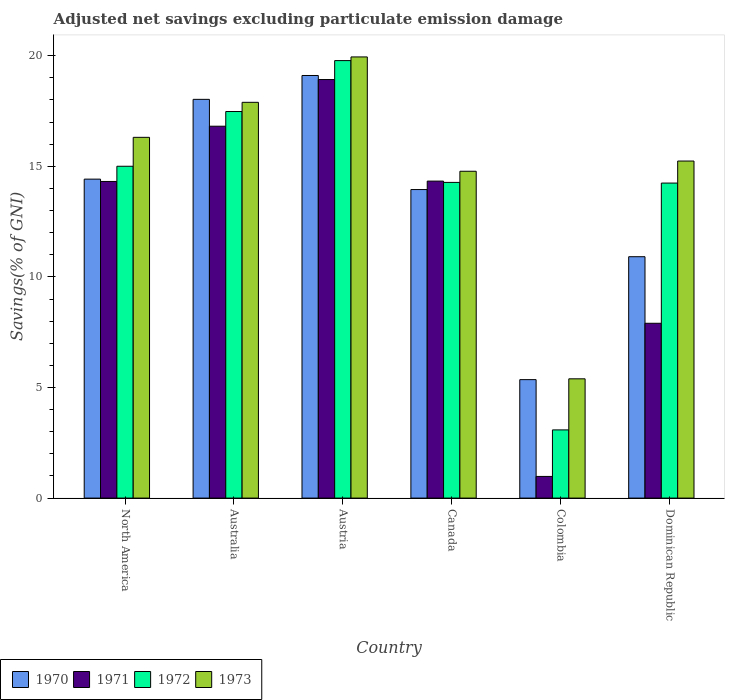How many different coloured bars are there?
Ensure brevity in your answer.  4. How many groups of bars are there?
Your response must be concise. 6. Are the number of bars per tick equal to the number of legend labels?
Offer a very short reply. Yes. How many bars are there on the 6th tick from the right?
Offer a very short reply. 4. What is the label of the 1st group of bars from the left?
Provide a short and direct response. North America. What is the adjusted net savings in 1972 in Colombia?
Make the answer very short. 3.08. Across all countries, what is the maximum adjusted net savings in 1971?
Provide a succinct answer. 18.92. Across all countries, what is the minimum adjusted net savings in 1970?
Ensure brevity in your answer.  5.36. In which country was the adjusted net savings in 1971 maximum?
Your answer should be compact. Austria. What is the total adjusted net savings in 1970 in the graph?
Your answer should be compact. 81.77. What is the difference between the adjusted net savings in 1971 in Austria and that in Dominican Republic?
Provide a short and direct response. 11.02. What is the difference between the adjusted net savings in 1973 in Dominican Republic and the adjusted net savings in 1972 in Australia?
Your response must be concise. -2.24. What is the average adjusted net savings in 1972 per country?
Provide a short and direct response. 13.98. What is the difference between the adjusted net savings of/in 1971 and adjusted net savings of/in 1972 in Canada?
Make the answer very short. 0.06. In how many countries, is the adjusted net savings in 1970 greater than 13 %?
Offer a terse response. 4. What is the ratio of the adjusted net savings in 1971 in Canada to that in Colombia?
Provide a short and direct response. 14.64. Is the adjusted net savings in 1972 in Australia less than that in Canada?
Your answer should be very brief. No. What is the difference between the highest and the second highest adjusted net savings in 1970?
Offer a very short reply. -1.08. What is the difference between the highest and the lowest adjusted net savings in 1973?
Give a very brief answer. 14.55. Is the sum of the adjusted net savings in 1973 in Canada and Colombia greater than the maximum adjusted net savings in 1970 across all countries?
Your answer should be very brief. Yes. Is it the case that in every country, the sum of the adjusted net savings in 1970 and adjusted net savings in 1972 is greater than the sum of adjusted net savings in 1971 and adjusted net savings in 1973?
Give a very brief answer. No. What does the 3rd bar from the left in Dominican Republic represents?
Make the answer very short. 1972. Is it the case that in every country, the sum of the adjusted net savings in 1973 and adjusted net savings in 1971 is greater than the adjusted net savings in 1970?
Your response must be concise. Yes. How many countries are there in the graph?
Provide a succinct answer. 6. Are the values on the major ticks of Y-axis written in scientific E-notation?
Provide a short and direct response. No. How are the legend labels stacked?
Keep it short and to the point. Horizontal. What is the title of the graph?
Give a very brief answer. Adjusted net savings excluding particulate emission damage. What is the label or title of the Y-axis?
Keep it short and to the point. Savings(% of GNI). What is the Savings(% of GNI) of 1970 in North America?
Ensure brevity in your answer.  14.42. What is the Savings(% of GNI) of 1971 in North America?
Provide a short and direct response. 14.31. What is the Savings(% of GNI) of 1972 in North America?
Make the answer very short. 15. What is the Savings(% of GNI) in 1973 in North America?
Make the answer very short. 16.31. What is the Savings(% of GNI) of 1970 in Australia?
Ensure brevity in your answer.  18.03. What is the Savings(% of GNI) of 1971 in Australia?
Give a very brief answer. 16.81. What is the Savings(% of GNI) in 1972 in Australia?
Offer a terse response. 17.48. What is the Savings(% of GNI) of 1973 in Australia?
Keep it short and to the point. 17.89. What is the Savings(% of GNI) in 1970 in Austria?
Give a very brief answer. 19.11. What is the Savings(% of GNI) in 1971 in Austria?
Provide a short and direct response. 18.92. What is the Savings(% of GNI) in 1972 in Austria?
Provide a succinct answer. 19.78. What is the Savings(% of GNI) in 1973 in Austria?
Your response must be concise. 19.94. What is the Savings(% of GNI) in 1970 in Canada?
Your answer should be compact. 13.95. What is the Savings(% of GNI) of 1971 in Canada?
Your answer should be compact. 14.33. What is the Savings(% of GNI) of 1972 in Canada?
Your answer should be compact. 14.27. What is the Savings(% of GNI) of 1973 in Canada?
Keep it short and to the point. 14.78. What is the Savings(% of GNI) of 1970 in Colombia?
Offer a very short reply. 5.36. What is the Savings(% of GNI) in 1971 in Colombia?
Keep it short and to the point. 0.98. What is the Savings(% of GNI) in 1972 in Colombia?
Your response must be concise. 3.08. What is the Savings(% of GNI) in 1973 in Colombia?
Ensure brevity in your answer.  5.39. What is the Savings(% of GNI) of 1970 in Dominican Republic?
Provide a short and direct response. 10.91. What is the Savings(% of GNI) of 1971 in Dominican Republic?
Ensure brevity in your answer.  7.9. What is the Savings(% of GNI) in 1972 in Dominican Republic?
Make the answer very short. 14.24. What is the Savings(% of GNI) of 1973 in Dominican Republic?
Ensure brevity in your answer.  15.24. Across all countries, what is the maximum Savings(% of GNI) in 1970?
Make the answer very short. 19.11. Across all countries, what is the maximum Savings(% of GNI) of 1971?
Your answer should be compact. 18.92. Across all countries, what is the maximum Savings(% of GNI) in 1972?
Your response must be concise. 19.78. Across all countries, what is the maximum Savings(% of GNI) in 1973?
Your answer should be compact. 19.94. Across all countries, what is the minimum Savings(% of GNI) of 1970?
Provide a short and direct response. 5.36. Across all countries, what is the minimum Savings(% of GNI) in 1971?
Offer a very short reply. 0.98. Across all countries, what is the minimum Savings(% of GNI) of 1972?
Provide a succinct answer. 3.08. Across all countries, what is the minimum Savings(% of GNI) in 1973?
Offer a very short reply. 5.39. What is the total Savings(% of GNI) of 1970 in the graph?
Give a very brief answer. 81.77. What is the total Savings(% of GNI) in 1971 in the graph?
Offer a terse response. 73.26. What is the total Savings(% of GNI) in 1972 in the graph?
Make the answer very short. 83.85. What is the total Savings(% of GNI) in 1973 in the graph?
Ensure brevity in your answer.  89.55. What is the difference between the Savings(% of GNI) of 1970 in North America and that in Australia?
Offer a very short reply. -3.61. What is the difference between the Savings(% of GNI) of 1971 in North America and that in Australia?
Your answer should be very brief. -2.5. What is the difference between the Savings(% of GNI) in 1972 in North America and that in Australia?
Offer a terse response. -2.47. What is the difference between the Savings(% of GNI) of 1973 in North America and that in Australia?
Offer a terse response. -1.58. What is the difference between the Savings(% of GNI) of 1970 in North America and that in Austria?
Provide a succinct answer. -4.69. What is the difference between the Savings(% of GNI) in 1971 in North America and that in Austria?
Keep it short and to the point. -4.61. What is the difference between the Savings(% of GNI) in 1972 in North America and that in Austria?
Provide a short and direct response. -4.78. What is the difference between the Savings(% of GNI) of 1973 in North America and that in Austria?
Ensure brevity in your answer.  -3.63. What is the difference between the Savings(% of GNI) of 1970 in North America and that in Canada?
Offer a very short reply. 0.47. What is the difference between the Savings(% of GNI) in 1971 in North America and that in Canada?
Ensure brevity in your answer.  -0.02. What is the difference between the Savings(% of GNI) in 1972 in North America and that in Canada?
Keep it short and to the point. 0.73. What is the difference between the Savings(% of GNI) of 1973 in North America and that in Canada?
Give a very brief answer. 1.53. What is the difference between the Savings(% of GNI) of 1970 in North America and that in Colombia?
Your answer should be very brief. 9.06. What is the difference between the Savings(% of GNI) in 1971 in North America and that in Colombia?
Offer a very short reply. 13.34. What is the difference between the Savings(% of GNI) of 1972 in North America and that in Colombia?
Your response must be concise. 11.92. What is the difference between the Savings(% of GNI) of 1973 in North America and that in Colombia?
Offer a terse response. 10.92. What is the difference between the Savings(% of GNI) of 1970 in North America and that in Dominican Republic?
Provide a succinct answer. 3.51. What is the difference between the Savings(% of GNI) of 1971 in North America and that in Dominican Republic?
Offer a very short reply. 6.41. What is the difference between the Savings(% of GNI) in 1972 in North America and that in Dominican Republic?
Your answer should be very brief. 0.76. What is the difference between the Savings(% of GNI) of 1973 in North America and that in Dominican Republic?
Keep it short and to the point. 1.07. What is the difference between the Savings(% of GNI) of 1970 in Australia and that in Austria?
Keep it short and to the point. -1.08. What is the difference between the Savings(% of GNI) of 1971 in Australia and that in Austria?
Give a very brief answer. -2.11. What is the difference between the Savings(% of GNI) of 1972 in Australia and that in Austria?
Your answer should be compact. -2.3. What is the difference between the Savings(% of GNI) of 1973 in Australia and that in Austria?
Offer a terse response. -2.05. What is the difference between the Savings(% of GNI) of 1970 in Australia and that in Canada?
Make the answer very short. 4.08. What is the difference between the Savings(% of GNI) of 1971 in Australia and that in Canada?
Give a very brief answer. 2.48. What is the difference between the Savings(% of GNI) of 1972 in Australia and that in Canada?
Offer a very short reply. 3.2. What is the difference between the Savings(% of GNI) in 1973 in Australia and that in Canada?
Your response must be concise. 3.12. What is the difference between the Savings(% of GNI) of 1970 in Australia and that in Colombia?
Offer a very short reply. 12.67. What is the difference between the Savings(% of GNI) of 1971 in Australia and that in Colombia?
Your answer should be compact. 15.83. What is the difference between the Savings(% of GNI) in 1972 in Australia and that in Colombia?
Offer a very short reply. 14.39. What is the difference between the Savings(% of GNI) of 1973 in Australia and that in Colombia?
Your answer should be compact. 12.5. What is the difference between the Savings(% of GNI) of 1970 in Australia and that in Dominican Republic?
Provide a succinct answer. 7.11. What is the difference between the Savings(% of GNI) in 1971 in Australia and that in Dominican Republic?
Make the answer very short. 8.91. What is the difference between the Savings(% of GNI) in 1972 in Australia and that in Dominican Republic?
Give a very brief answer. 3.23. What is the difference between the Savings(% of GNI) of 1973 in Australia and that in Dominican Republic?
Offer a very short reply. 2.65. What is the difference between the Savings(% of GNI) of 1970 in Austria and that in Canada?
Offer a very short reply. 5.16. What is the difference between the Savings(% of GNI) of 1971 in Austria and that in Canada?
Provide a succinct answer. 4.59. What is the difference between the Savings(% of GNI) of 1972 in Austria and that in Canada?
Your answer should be very brief. 5.51. What is the difference between the Savings(% of GNI) in 1973 in Austria and that in Canada?
Provide a short and direct response. 5.17. What is the difference between the Savings(% of GNI) in 1970 in Austria and that in Colombia?
Provide a short and direct response. 13.75. What is the difference between the Savings(% of GNI) in 1971 in Austria and that in Colombia?
Your response must be concise. 17.94. What is the difference between the Savings(% of GNI) in 1972 in Austria and that in Colombia?
Provide a succinct answer. 16.7. What is the difference between the Savings(% of GNI) in 1973 in Austria and that in Colombia?
Provide a succinct answer. 14.55. What is the difference between the Savings(% of GNI) in 1970 in Austria and that in Dominican Republic?
Keep it short and to the point. 8.19. What is the difference between the Savings(% of GNI) in 1971 in Austria and that in Dominican Republic?
Give a very brief answer. 11.02. What is the difference between the Savings(% of GNI) in 1972 in Austria and that in Dominican Republic?
Offer a terse response. 5.54. What is the difference between the Savings(% of GNI) in 1973 in Austria and that in Dominican Republic?
Keep it short and to the point. 4.71. What is the difference between the Savings(% of GNI) of 1970 in Canada and that in Colombia?
Offer a very short reply. 8.59. What is the difference between the Savings(% of GNI) in 1971 in Canada and that in Colombia?
Your answer should be compact. 13.35. What is the difference between the Savings(% of GNI) in 1972 in Canada and that in Colombia?
Ensure brevity in your answer.  11.19. What is the difference between the Savings(% of GNI) in 1973 in Canada and that in Colombia?
Offer a very short reply. 9.38. What is the difference between the Savings(% of GNI) in 1970 in Canada and that in Dominican Republic?
Make the answer very short. 3.04. What is the difference between the Savings(% of GNI) in 1971 in Canada and that in Dominican Republic?
Your response must be concise. 6.43. What is the difference between the Savings(% of GNI) in 1972 in Canada and that in Dominican Republic?
Keep it short and to the point. 0.03. What is the difference between the Savings(% of GNI) in 1973 in Canada and that in Dominican Republic?
Give a very brief answer. -0.46. What is the difference between the Savings(% of GNI) of 1970 in Colombia and that in Dominican Republic?
Ensure brevity in your answer.  -5.56. What is the difference between the Savings(% of GNI) of 1971 in Colombia and that in Dominican Republic?
Offer a very short reply. -6.92. What is the difference between the Savings(% of GNI) in 1972 in Colombia and that in Dominican Republic?
Make the answer very short. -11.16. What is the difference between the Savings(% of GNI) of 1973 in Colombia and that in Dominican Republic?
Keep it short and to the point. -9.85. What is the difference between the Savings(% of GNI) of 1970 in North America and the Savings(% of GNI) of 1971 in Australia?
Provide a short and direct response. -2.39. What is the difference between the Savings(% of GNI) in 1970 in North America and the Savings(% of GNI) in 1972 in Australia?
Keep it short and to the point. -3.06. What is the difference between the Savings(% of GNI) in 1970 in North America and the Savings(% of GNI) in 1973 in Australia?
Offer a very short reply. -3.47. What is the difference between the Savings(% of GNI) in 1971 in North America and the Savings(% of GNI) in 1972 in Australia?
Ensure brevity in your answer.  -3.16. What is the difference between the Savings(% of GNI) of 1971 in North America and the Savings(% of GNI) of 1973 in Australia?
Provide a short and direct response. -3.58. What is the difference between the Savings(% of GNI) in 1972 in North America and the Savings(% of GNI) in 1973 in Australia?
Your answer should be very brief. -2.89. What is the difference between the Savings(% of GNI) of 1970 in North America and the Savings(% of GNI) of 1971 in Austria?
Give a very brief answer. -4.5. What is the difference between the Savings(% of GNI) in 1970 in North America and the Savings(% of GNI) in 1972 in Austria?
Offer a very short reply. -5.36. What is the difference between the Savings(% of GNI) of 1970 in North America and the Savings(% of GNI) of 1973 in Austria?
Offer a terse response. -5.52. What is the difference between the Savings(% of GNI) of 1971 in North America and the Savings(% of GNI) of 1972 in Austria?
Your answer should be compact. -5.46. What is the difference between the Savings(% of GNI) of 1971 in North America and the Savings(% of GNI) of 1973 in Austria?
Ensure brevity in your answer.  -5.63. What is the difference between the Savings(% of GNI) in 1972 in North America and the Savings(% of GNI) in 1973 in Austria?
Your answer should be very brief. -4.94. What is the difference between the Savings(% of GNI) in 1970 in North America and the Savings(% of GNI) in 1971 in Canada?
Ensure brevity in your answer.  0.09. What is the difference between the Savings(% of GNI) of 1970 in North America and the Savings(% of GNI) of 1972 in Canada?
Keep it short and to the point. 0.15. What is the difference between the Savings(% of GNI) of 1970 in North America and the Savings(% of GNI) of 1973 in Canada?
Ensure brevity in your answer.  -0.36. What is the difference between the Savings(% of GNI) of 1971 in North America and the Savings(% of GNI) of 1972 in Canada?
Your answer should be very brief. 0.04. What is the difference between the Savings(% of GNI) of 1971 in North America and the Savings(% of GNI) of 1973 in Canada?
Keep it short and to the point. -0.46. What is the difference between the Savings(% of GNI) in 1972 in North America and the Savings(% of GNI) in 1973 in Canada?
Your answer should be very brief. 0.23. What is the difference between the Savings(% of GNI) of 1970 in North America and the Savings(% of GNI) of 1971 in Colombia?
Give a very brief answer. 13.44. What is the difference between the Savings(% of GNI) in 1970 in North America and the Savings(% of GNI) in 1972 in Colombia?
Your answer should be very brief. 11.34. What is the difference between the Savings(% of GNI) of 1970 in North America and the Savings(% of GNI) of 1973 in Colombia?
Your answer should be compact. 9.03. What is the difference between the Savings(% of GNI) of 1971 in North America and the Savings(% of GNI) of 1972 in Colombia?
Make the answer very short. 11.23. What is the difference between the Savings(% of GNI) in 1971 in North America and the Savings(% of GNI) in 1973 in Colombia?
Give a very brief answer. 8.92. What is the difference between the Savings(% of GNI) in 1972 in North America and the Savings(% of GNI) in 1973 in Colombia?
Your response must be concise. 9.61. What is the difference between the Savings(% of GNI) in 1970 in North America and the Savings(% of GNI) in 1971 in Dominican Republic?
Your answer should be very brief. 6.52. What is the difference between the Savings(% of GNI) of 1970 in North America and the Savings(% of GNI) of 1972 in Dominican Republic?
Give a very brief answer. 0.18. What is the difference between the Savings(% of GNI) of 1970 in North America and the Savings(% of GNI) of 1973 in Dominican Republic?
Your answer should be compact. -0.82. What is the difference between the Savings(% of GNI) of 1971 in North America and the Savings(% of GNI) of 1972 in Dominican Republic?
Give a very brief answer. 0.07. What is the difference between the Savings(% of GNI) in 1971 in North America and the Savings(% of GNI) in 1973 in Dominican Republic?
Offer a terse response. -0.92. What is the difference between the Savings(% of GNI) in 1972 in North America and the Savings(% of GNI) in 1973 in Dominican Republic?
Your response must be concise. -0.24. What is the difference between the Savings(% of GNI) in 1970 in Australia and the Savings(% of GNI) in 1971 in Austria?
Provide a short and direct response. -0.9. What is the difference between the Savings(% of GNI) in 1970 in Australia and the Savings(% of GNI) in 1972 in Austria?
Your answer should be very brief. -1.75. What is the difference between the Savings(% of GNI) of 1970 in Australia and the Savings(% of GNI) of 1973 in Austria?
Ensure brevity in your answer.  -1.92. What is the difference between the Savings(% of GNI) in 1971 in Australia and the Savings(% of GNI) in 1972 in Austria?
Your answer should be very brief. -2.97. What is the difference between the Savings(% of GNI) of 1971 in Australia and the Savings(% of GNI) of 1973 in Austria?
Your answer should be very brief. -3.13. What is the difference between the Savings(% of GNI) of 1972 in Australia and the Savings(% of GNI) of 1973 in Austria?
Ensure brevity in your answer.  -2.47. What is the difference between the Savings(% of GNI) in 1970 in Australia and the Savings(% of GNI) in 1971 in Canada?
Give a very brief answer. 3.7. What is the difference between the Savings(% of GNI) of 1970 in Australia and the Savings(% of GNI) of 1972 in Canada?
Offer a very short reply. 3.75. What is the difference between the Savings(% of GNI) of 1970 in Australia and the Savings(% of GNI) of 1973 in Canada?
Keep it short and to the point. 3.25. What is the difference between the Savings(% of GNI) in 1971 in Australia and the Savings(% of GNI) in 1972 in Canada?
Give a very brief answer. 2.54. What is the difference between the Savings(% of GNI) of 1971 in Australia and the Savings(% of GNI) of 1973 in Canada?
Provide a short and direct response. 2.04. What is the difference between the Savings(% of GNI) in 1972 in Australia and the Savings(% of GNI) in 1973 in Canada?
Make the answer very short. 2.7. What is the difference between the Savings(% of GNI) of 1970 in Australia and the Savings(% of GNI) of 1971 in Colombia?
Keep it short and to the point. 17.05. What is the difference between the Savings(% of GNI) of 1970 in Australia and the Savings(% of GNI) of 1972 in Colombia?
Keep it short and to the point. 14.94. What is the difference between the Savings(% of GNI) of 1970 in Australia and the Savings(% of GNI) of 1973 in Colombia?
Offer a terse response. 12.63. What is the difference between the Savings(% of GNI) in 1971 in Australia and the Savings(% of GNI) in 1972 in Colombia?
Offer a terse response. 13.73. What is the difference between the Savings(% of GNI) in 1971 in Australia and the Savings(% of GNI) in 1973 in Colombia?
Keep it short and to the point. 11.42. What is the difference between the Savings(% of GNI) in 1972 in Australia and the Savings(% of GNI) in 1973 in Colombia?
Offer a very short reply. 12.08. What is the difference between the Savings(% of GNI) of 1970 in Australia and the Savings(% of GNI) of 1971 in Dominican Republic?
Ensure brevity in your answer.  10.12. What is the difference between the Savings(% of GNI) of 1970 in Australia and the Savings(% of GNI) of 1972 in Dominican Republic?
Your answer should be compact. 3.78. What is the difference between the Savings(% of GNI) of 1970 in Australia and the Savings(% of GNI) of 1973 in Dominican Republic?
Your response must be concise. 2.79. What is the difference between the Savings(% of GNI) in 1971 in Australia and the Savings(% of GNI) in 1972 in Dominican Republic?
Your answer should be very brief. 2.57. What is the difference between the Savings(% of GNI) of 1971 in Australia and the Savings(% of GNI) of 1973 in Dominican Republic?
Your answer should be compact. 1.57. What is the difference between the Savings(% of GNI) of 1972 in Australia and the Savings(% of GNI) of 1973 in Dominican Republic?
Provide a short and direct response. 2.24. What is the difference between the Savings(% of GNI) of 1970 in Austria and the Savings(% of GNI) of 1971 in Canada?
Your answer should be very brief. 4.77. What is the difference between the Savings(% of GNI) of 1970 in Austria and the Savings(% of GNI) of 1972 in Canada?
Offer a terse response. 4.83. What is the difference between the Savings(% of GNI) in 1970 in Austria and the Savings(% of GNI) in 1973 in Canada?
Give a very brief answer. 4.33. What is the difference between the Savings(% of GNI) in 1971 in Austria and the Savings(% of GNI) in 1972 in Canada?
Make the answer very short. 4.65. What is the difference between the Savings(% of GNI) of 1971 in Austria and the Savings(% of GNI) of 1973 in Canada?
Provide a succinct answer. 4.15. What is the difference between the Savings(% of GNI) of 1972 in Austria and the Savings(% of GNI) of 1973 in Canada?
Ensure brevity in your answer.  5. What is the difference between the Savings(% of GNI) in 1970 in Austria and the Savings(% of GNI) in 1971 in Colombia?
Offer a very short reply. 18.13. What is the difference between the Savings(% of GNI) of 1970 in Austria and the Savings(% of GNI) of 1972 in Colombia?
Your answer should be very brief. 16.02. What is the difference between the Savings(% of GNI) of 1970 in Austria and the Savings(% of GNI) of 1973 in Colombia?
Your response must be concise. 13.71. What is the difference between the Savings(% of GNI) of 1971 in Austria and the Savings(% of GNI) of 1972 in Colombia?
Your answer should be compact. 15.84. What is the difference between the Savings(% of GNI) of 1971 in Austria and the Savings(% of GNI) of 1973 in Colombia?
Offer a very short reply. 13.53. What is the difference between the Savings(% of GNI) of 1972 in Austria and the Savings(% of GNI) of 1973 in Colombia?
Ensure brevity in your answer.  14.39. What is the difference between the Savings(% of GNI) of 1970 in Austria and the Savings(% of GNI) of 1971 in Dominican Republic?
Provide a succinct answer. 11.2. What is the difference between the Savings(% of GNI) of 1970 in Austria and the Savings(% of GNI) of 1972 in Dominican Republic?
Your response must be concise. 4.86. What is the difference between the Savings(% of GNI) of 1970 in Austria and the Savings(% of GNI) of 1973 in Dominican Republic?
Your answer should be compact. 3.87. What is the difference between the Savings(% of GNI) of 1971 in Austria and the Savings(% of GNI) of 1972 in Dominican Republic?
Provide a short and direct response. 4.68. What is the difference between the Savings(% of GNI) in 1971 in Austria and the Savings(% of GNI) in 1973 in Dominican Republic?
Provide a succinct answer. 3.68. What is the difference between the Savings(% of GNI) in 1972 in Austria and the Savings(% of GNI) in 1973 in Dominican Republic?
Your answer should be very brief. 4.54. What is the difference between the Savings(% of GNI) of 1970 in Canada and the Savings(% of GNI) of 1971 in Colombia?
Offer a terse response. 12.97. What is the difference between the Savings(% of GNI) of 1970 in Canada and the Savings(% of GNI) of 1972 in Colombia?
Your answer should be very brief. 10.87. What is the difference between the Savings(% of GNI) of 1970 in Canada and the Savings(% of GNI) of 1973 in Colombia?
Provide a short and direct response. 8.56. What is the difference between the Savings(% of GNI) in 1971 in Canada and the Savings(% of GNI) in 1972 in Colombia?
Make the answer very short. 11.25. What is the difference between the Savings(% of GNI) of 1971 in Canada and the Savings(% of GNI) of 1973 in Colombia?
Offer a terse response. 8.94. What is the difference between the Savings(% of GNI) of 1972 in Canada and the Savings(% of GNI) of 1973 in Colombia?
Ensure brevity in your answer.  8.88. What is the difference between the Savings(% of GNI) of 1970 in Canada and the Savings(% of GNI) of 1971 in Dominican Republic?
Your answer should be very brief. 6.05. What is the difference between the Savings(% of GNI) in 1970 in Canada and the Savings(% of GNI) in 1972 in Dominican Republic?
Offer a terse response. -0.29. What is the difference between the Savings(% of GNI) of 1970 in Canada and the Savings(% of GNI) of 1973 in Dominican Republic?
Your answer should be compact. -1.29. What is the difference between the Savings(% of GNI) of 1971 in Canada and the Savings(% of GNI) of 1972 in Dominican Republic?
Offer a terse response. 0.09. What is the difference between the Savings(% of GNI) in 1971 in Canada and the Savings(% of GNI) in 1973 in Dominican Republic?
Make the answer very short. -0.91. What is the difference between the Savings(% of GNI) in 1972 in Canada and the Savings(% of GNI) in 1973 in Dominican Republic?
Ensure brevity in your answer.  -0.97. What is the difference between the Savings(% of GNI) in 1970 in Colombia and the Savings(% of GNI) in 1971 in Dominican Republic?
Keep it short and to the point. -2.55. What is the difference between the Savings(% of GNI) in 1970 in Colombia and the Savings(% of GNI) in 1972 in Dominican Republic?
Your answer should be very brief. -8.89. What is the difference between the Savings(% of GNI) in 1970 in Colombia and the Savings(% of GNI) in 1973 in Dominican Republic?
Your answer should be compact. -9.88. What is the difference between the Savings(% of GNI) of 1971 in Colombia and the Savings(% of GNI) of 1972 in Dominican Republic?
Provide a succinct answer. -13.26. What is the difference between the Savings(% of GNI) in 1971 in Colombia and the Savings(% of GNI) in 1973 in Dominican Republic?
Keep it short and to the point. -14.26. What is the difference between the Savings(% of GNI) in 1972 in Colombia and the Savings(% of GNI) in 1973 in Dominican Republic?
Keep it short and to the point. -12.15. What is the average Savings(% of GNI) in 1970 per country?
Provide a succinct answer. 13.63. What is the average Savings(% of GNI) in 1971 per country?
Your answer should be very brief. 12.21. What is the average Savings(% of GNI) in 1972 per country?
Make the answer very short. 13.98. What is the average Savings(% of GNI) of 1973 per country?
Keep it short and to the point. 14.93. What is the difference between the Savings(% of GNI) of 1970 and Savings(% of GNI) of 1971 in North America?
Ensure brevity in your answer.  0.11. What is the difference between the Savings(% of GNI) in 1970 and Savings(% of GNI) in 1972 in North America?
Provide a short and direct response. -0.58. What is the difference between the Savings(% of GNI) of 1970 and Savings(% of GNI) of 1973 in North America?
Offer a very short reply. -1.89. What is the difference between the Savings(% of GNI) in 1971 and Savings(% of GNI) in 1972 in North America?
Keep it short and to the point. -0.69. What is the difference between the Savings(% of GNI) of 1971 and Savings(% of GNI) of 1973 in North America?
Your response must be concise. -2. What is the difference between the Savings(% of GNI) in 1972 and Savings(% of GNI) in 1973 in North America?
Keep it short and to the point. -1.31. What is the difference between the Savings(% of GNI) of 1970 and Savings(% of GNI) of 1971 in Australia?
Offer a terse response. 1.21. What is the difference between the Savings(% of GNI) in 1970 and Savings(% of GNI) in 1972 in Australia?
Make the answer very short. 0.55. What is the difference between the Savings(% of GNI) of 1970 and Savings(% of GNI) of 1973 in Australia?
Your answer should be very brief. 0.13. What is the difference between the Savings(% of GNI) in 1971 and Savings(% of GNI) in 1972 in Australia?
Provide a succinct answer. -0.66. What is the difference between the Savings(% of GNI) in 1971 and Savings(% of GNI) in 1973 in Australia?
Provide a short and direct response. -1.08. What is the difference between the Savings(% of GNI) in 1972 and Savings(% of GNI) in 1973 in Australia?
Make the answer very short. -0.42. What is the difference between the Savings(% of GNI) of 1970 and Savings(% of GNI) of 1971 in Austria?
Your answer should be compact. 0.18. What is the difference between the Savings(% of GNI) in 1970 and Savings(% of GNI) in 1972 in Austria?
Your response must be concise. -0.67. What is the difference between the Savings(% of GNI) in 1970 and Savings(% of GNI) in 1973 in Austria?
Your answer should be very brief. -0.84. What is the difference between the Savings(% of GNI) of 1971 and Savings(% of GNI) of 1972 in Austria?
Keep it short and to the point. -0.86. What is the difference between the Savings(% of GNI) in 1971 and Savings(% of GNI) in 1973 in Austria?
Offer a terse response. -1.02. What is the difference between the Savings(% of GNI) in 1972 and Savings(% of GNI) in 1973 in Austria?
Provide a succinct answer. -0.17. What is the difference between the Savings(% of GNI) of 1970 and Savings(% of GNI) of 1971 in Canada?
Offer a terse response. -0.38. What is the difference between the Savings(% of GNI) of 1970 and Savings(% of GNI) of 1972 in Canada?
Your answer should be compact. -0.32. What is the difference between the Savings(% of GNI) of 1970 and Savings(% of GNI) of 1973 in Canada?
Offer a very short reply. -0.83. What is the difference between the Savings(% of GNI) in 1971 and Savings(% of GNI) in 1972 in Canada?
Your answer should be very brief. 0.06. What is the difference between the Savings(% of GNI) of 1971 and Savings(% of GNI) of 1973 in Canada?
Ensure brevity in your answer.  -0.45. What is the difference between the Savings(% of GNI) in 1972 and Savings(% of GNI) in 1973 in Canada?
Your answer should be very brief. -0.5. What is the difference between the Savings(% of GNI) of 1970 and Savings(% of GNI) of 1971 in Colombia?
Give a very brief answer. 4.38. What is the difference between the Savings(% of GNI) in 1970 and Savings(% of GNI) in 1972 in Colombia?
Your answer should be compact. 2.27. What is the difference between the Savings(% of GNI) in 1970 and Savings(% of GNI) in 1973 in Colombia?
Give a very brief answer. -0.04. What is the difference between the Savings(% of GNI) of 1971 and Savings(% of GNI) of 1972 in Colombia?
Offer a very short reply. -2.1. What is the difference between the Savings(% of GNI) of 1971 and Savings(% of GNI) of 1973 in Colombia?
Offer a terse response. -4.41. What is the difference between the Savings(% of GNI) of 1972 and Savings(% of GNI) of 1973 in Colombia?
Offer a very short reply. -2.31. What is the difference between the Savings(% of GNI) of 1970 and Savings(% of GNI) of 1971 in Dominican Republic?
Offer a terse response. 3.01. What is the difference between the Savings(% of GNI) in 1970 and Savings(% of GNI) in 1972 in Dominican Republic?
Your answer should be very brief. -3.33. What is the difference between the Savings(% of GNI) of 1970 and Savings(% of GNI) of 1973 in Dominican Republic?
Keep it short and to the point. -4.33. What is the difference between the Savings(% of GNI) of 1971 and Savings(% of GNI) of 1972 in Dominican Republic?
Ensure brevity in your answer.  -6.34. What is the difference between the Savings(% of GNI) in 1971 and Savings(% of GNI) in 1973 in Dominican Republic?
Provide a succinct answer. -7.33. What is the difference between the Savings(% of GNI) of 1972 and Savings(% of GNI) of 1973 in Dominican Republic?
Your answer should be compact. -1. What is the ratio of the Savings(% of GNI) in 1970 in North America to that in Australia?
Keep it short and to the point. 0.8. What is the ratio of the Savings(% of GNI) of 1971 in North America to that in Australia?
Keep it short and to the point. 0.85. What is the ratio of the Savings(% of GNI) of 1972 in North America to that in Australia?
Make the answer very short. 0.86. What is the ratio of the Savings(% of GNI) of 1973 in North America to that in Australia?
Provide a short and direct response. 0.91. What is the ratio of the Savings(% of GNI) of 1970 in North America to that in Austria?
Provide a succinct answer. 0.75. What is the ratio of the Savings(% of GNI) of 1971 in North America to that in Austria?
Provide a short and direct response. 0.76. What is the ratio of the Savings(% of GNI) in 1972 in North America to that in Austria?
Make the answer very short. 0.76. What is the ratio of the Savings(% of GNI) in 1973 in North America to that in Austria?
Offer a very short reply. 0.82. What is the ratio of the Savings(% of GNI) in 1970 in North America to that in Canada?
Make the answer very short. 1.03. What is the ratio of the Savings(% of GNI) of 1971 in North America to that in Canada?
Offer a terse response. 1. What is the ratio of the Savings(% of GNI) in 1972 in North America to that in Canada?
Your answer should be compact. 1.05. What is the ratio of the Savings(% of GNI) in 1973 in North America to that in Canada?
Provide a succinct answer. 1.1. What is the ratio of the Savings(% of GNI) in 1970 in North America to that in Colombia?
Offer a terse response. 2.69. What is the ratio of the Savings(% of GNI) of 1971 in North America to that in Colombia?
Keep it short and to the point. 14.62. What is the ratio of the Savings(% of GNI) of 1972 in North America to that in Colombia?
Provide a short and direct response. 4.87. What is the ratio of the Savings(% of GNI) of 1973 in North America to that in Colombia?
Your answer should be very brief. 3.02. What is the ratio of the Savings(% of GNI) of 1970 in North America to that in Dominican Republic?
Your answer should be very brief. 1.32. What is the ratio of the Savings(% of GNI) in 1971 in North America to that in Dominican Republic?
Ensure brevity in your answer.  1.81. What is the ratio of the Savings(% of GNI) of 1972 in North America to that in Dominican Republic?
Offer a very short reply. 1.05. What is the ratio of the Savings(% of GNI) in 1973 in North America to that in Dominican Republic?
Offer a very short reply. 1.07. What is the ratio of the Savings(% of GNI) in 1970 in Australia to that in Austria?
Your answer should be very brief. 0.94. What is the ratio of the Savings(% of GNI) in 1971 in Australia to that in Austria?
Provide a short and direct response. 0.89. What is the ratio of the Savings(% of GNI) in 1972 in Australia to that in Austria?
Provide a succinct answer. 0.88. What is the ratio of the Savings(% of GNI) of 1973 in Australia to that in Austria?
Offer a terse response. 0.9. What is the ratio of the Savings(% of GNI) in 1970 in Australia to that in Canada?
Keep it short and to the point. 1.29. What is the ratio of the Savings(% of GNI) of 1971 in Australia to that in Canada?
Provide a succinct answer. 1.17. What is the ratio of the Savings(% of GNI) in 1972 in Australia to that in Canada?
Provide a short and direct response. 1.22. What is the ratio of the Savings(% of GNI) in 1973 in Australia to that in Canada?
Offer a terse response. 1.21. What is the ratio of the Savings(% of GNI) of 1970 in Australia to that in Colombia?
Your answer should be very brief. 3.37. What is the ratio of the Savings(% of GNI) of 1971 in Australia to that in Colombia?
Offer a terse response. 17.17. What is the ratio of the Savings(% of GNI) in 1972 in Australia to that in Colombia?
Provide a short and direct response. 5.67. What is the ratio of the Savings(% of GNI) in 1973 in Australia to that in Colombia?
Offer a very short reply. 3.32. What is the ratio of the Savings(% of GNI) of 1970 in Australia to that in Dominican Republic?
Provide a short and direct response. 1.65. What is the ratio of the Savings(% of GNI) in 1971 in Australia to that in Dominican Republic?
Your response must be concise. 2.13. What is the ratio of the Savings(% of GNI) in 1972 in Australia to that in Dominican Republic?
Offer a terse response. 1.23. What is the ratio of the Savings(% of GNI) of 1973 in Australia to that in Dominican Republic?
Offer a very short reply. 1.17. What is the ratio of the Savings(% of GNI) of 1970 in Austria to that in Canada?
Keep it short and to the point. 1.37. What is the ratio of the Savings(% of GNI) in 1971 in Austria to that in Canada?
Keep it short and to the point. 1.32. What is the ratio of the Savings(% of GNI) of 1972 in Austria to that in Canada?
Offer a very short reply. 1.39. What is the ratio of the Savings(% of GNI) of 1973 in Austria to that in Canada?
Give a very brief answer. 1.35. What is the ratio of the Savings(% of GNI) in 1970 in Austria to that in Colombia?
Give a very brief answer. 3.57. What is the ratio of the Savings(% of GNI) in 1971 in Austria to that in Colombia?
Offer a very short reply. 19.32. What is the ratio of the Savings(% of GNI) in 1972 in Austria to that in Colombia?
Provide a succinct answer. 6.42. What is the ratio of the Savings(% of GNI) of 1973 in Austria to that in Colombia?
Give a very brief answer. 3.7. What is the ratio of the Savings(% of GNI) in 1970 in Austria to that in Dominican Republic?
Your response must be concise. 1.75. What is the ratio of the Savings(% of GNI) of 1971 in Austria to that in Dominican Republic?
Offer a terse response. 2.39. What is the ratio of the Savings(% of GNI) of 1972 in Austria to that in Dominican Republic?
Your response must be concise. 1.39. What is the ratio of the Savings(% of GNI) of 1973 in Austria to that in Dominican Republic?
Your answer should be compact. 1.31. What is the ratio of the Savings(% of GNI) in 1970 in Canada to that in Colombia?
Provide a succinct answer. 2.6. What is the ratio of the Savings(% of GNI) of 1971 in Canada to that in Colombia?
Provide a short and direct response. 14.64. What is the ratio of the Savings(% of GNI) of 1972 in Canada to that in Colombia?
Offer a very short reply. 4.63. What is the ratio of the Savings(% of GNI) of 1973 in Canada to that in Colombia?
Ensure brevity in your answer.  2.74. What is the ratio of the Savings(% of GNI) of 1970 in Canada to that in Dominican Republic?
Provide a short and direct response. 1.28. What is the ratio of the Savings(% of GNI) of 1971 in Canada to that in Dominican Republic?
Your answer should be very brief. 1.81. What is the ratio of the Savings(% of GNI) of 1973 in Canada to that in Dominican Republic?
Ensure brevity in your answer.  0.97. What is the ratio of the Savings(% of GNI) in 1970 in Colombia to that in Dominican Republic?
Your answer should be very brief. 0.49. What is the ratio of the Savings(% of GNI) of 1971 in Colombia to that in Dominican Republic?
Give a very brief answer. 0.12. What is the ratio of the Savings(% of GNI) in 1972 in Colombia to that in Dominican Republic?
Provide a succinct answer. 0.22. What is the ratio of the Savings(% of GNI) of 1973 in Colombia to that in Dominican Republic?
Your answer should be very brief. 0.35. What is the difference between the highest and the second highest Savings(% of GNI) in 1970?
Ensure brevity in your answer.  1.08. What is the difference between the highest and the second highest Savings(% of GNI) in 1971?
Ensure brevity in your answer.  2.11. What is the difference between the highest and the second highest Savings(% of GNI) in 1972?
Keep it short and to the point. 2.3. What is the difference between the highest and the second highest Savings(% of GNI) in 1973?
Offer a terse response. 2.05. What is the difference between the highest and the lowest Savings(% of GNI) in 1970?
Provide a succinct answer. 13.75. What is the difference between the highest and the lowest Savings(% of GNI) in 1971?
Offer a terse response. 17.94. What is the difference between the highest and the lowest Savings(% of GNI) in 1972?
Ensure brevity in your answer.  16.7. What is the difference between the highest and the lowest Savings(% of GNI) of 1973?
Give a very brief answer. 14.55. 